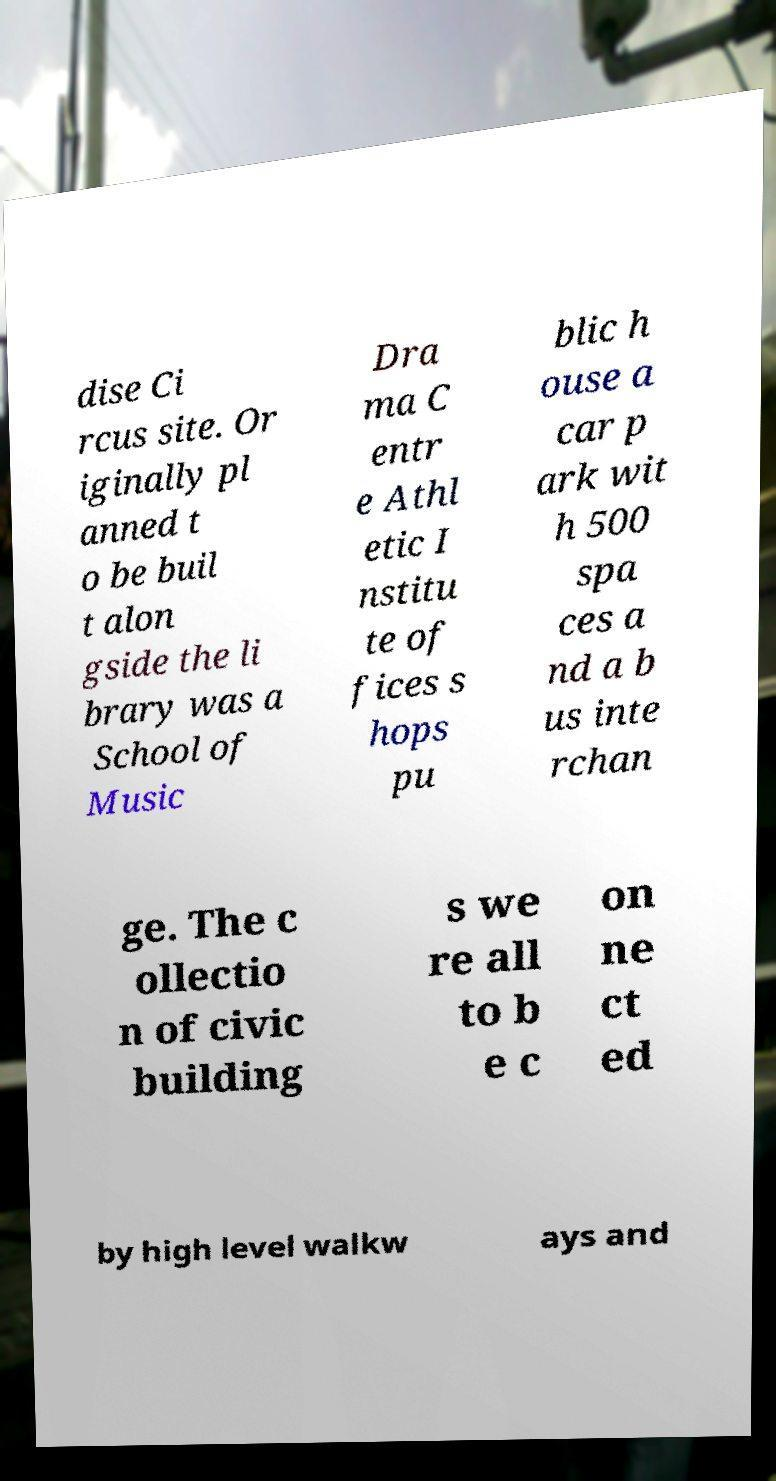There's text embedded in this image that I need extracted. Can you transcribe it verbatim? dise Ci rcus site. Or iginally pl anned t o be buil t alon gside the li brary was a School of Music Dra ma C entr e Athl etic I nstitu te of fices s hops pu blic h ouse a car p ark wit h 500 spa ces a nd a b us inte rchan ge. The c ollectio n of civic building s we re all to b e c on ne ct ed by high level walkw ays and 